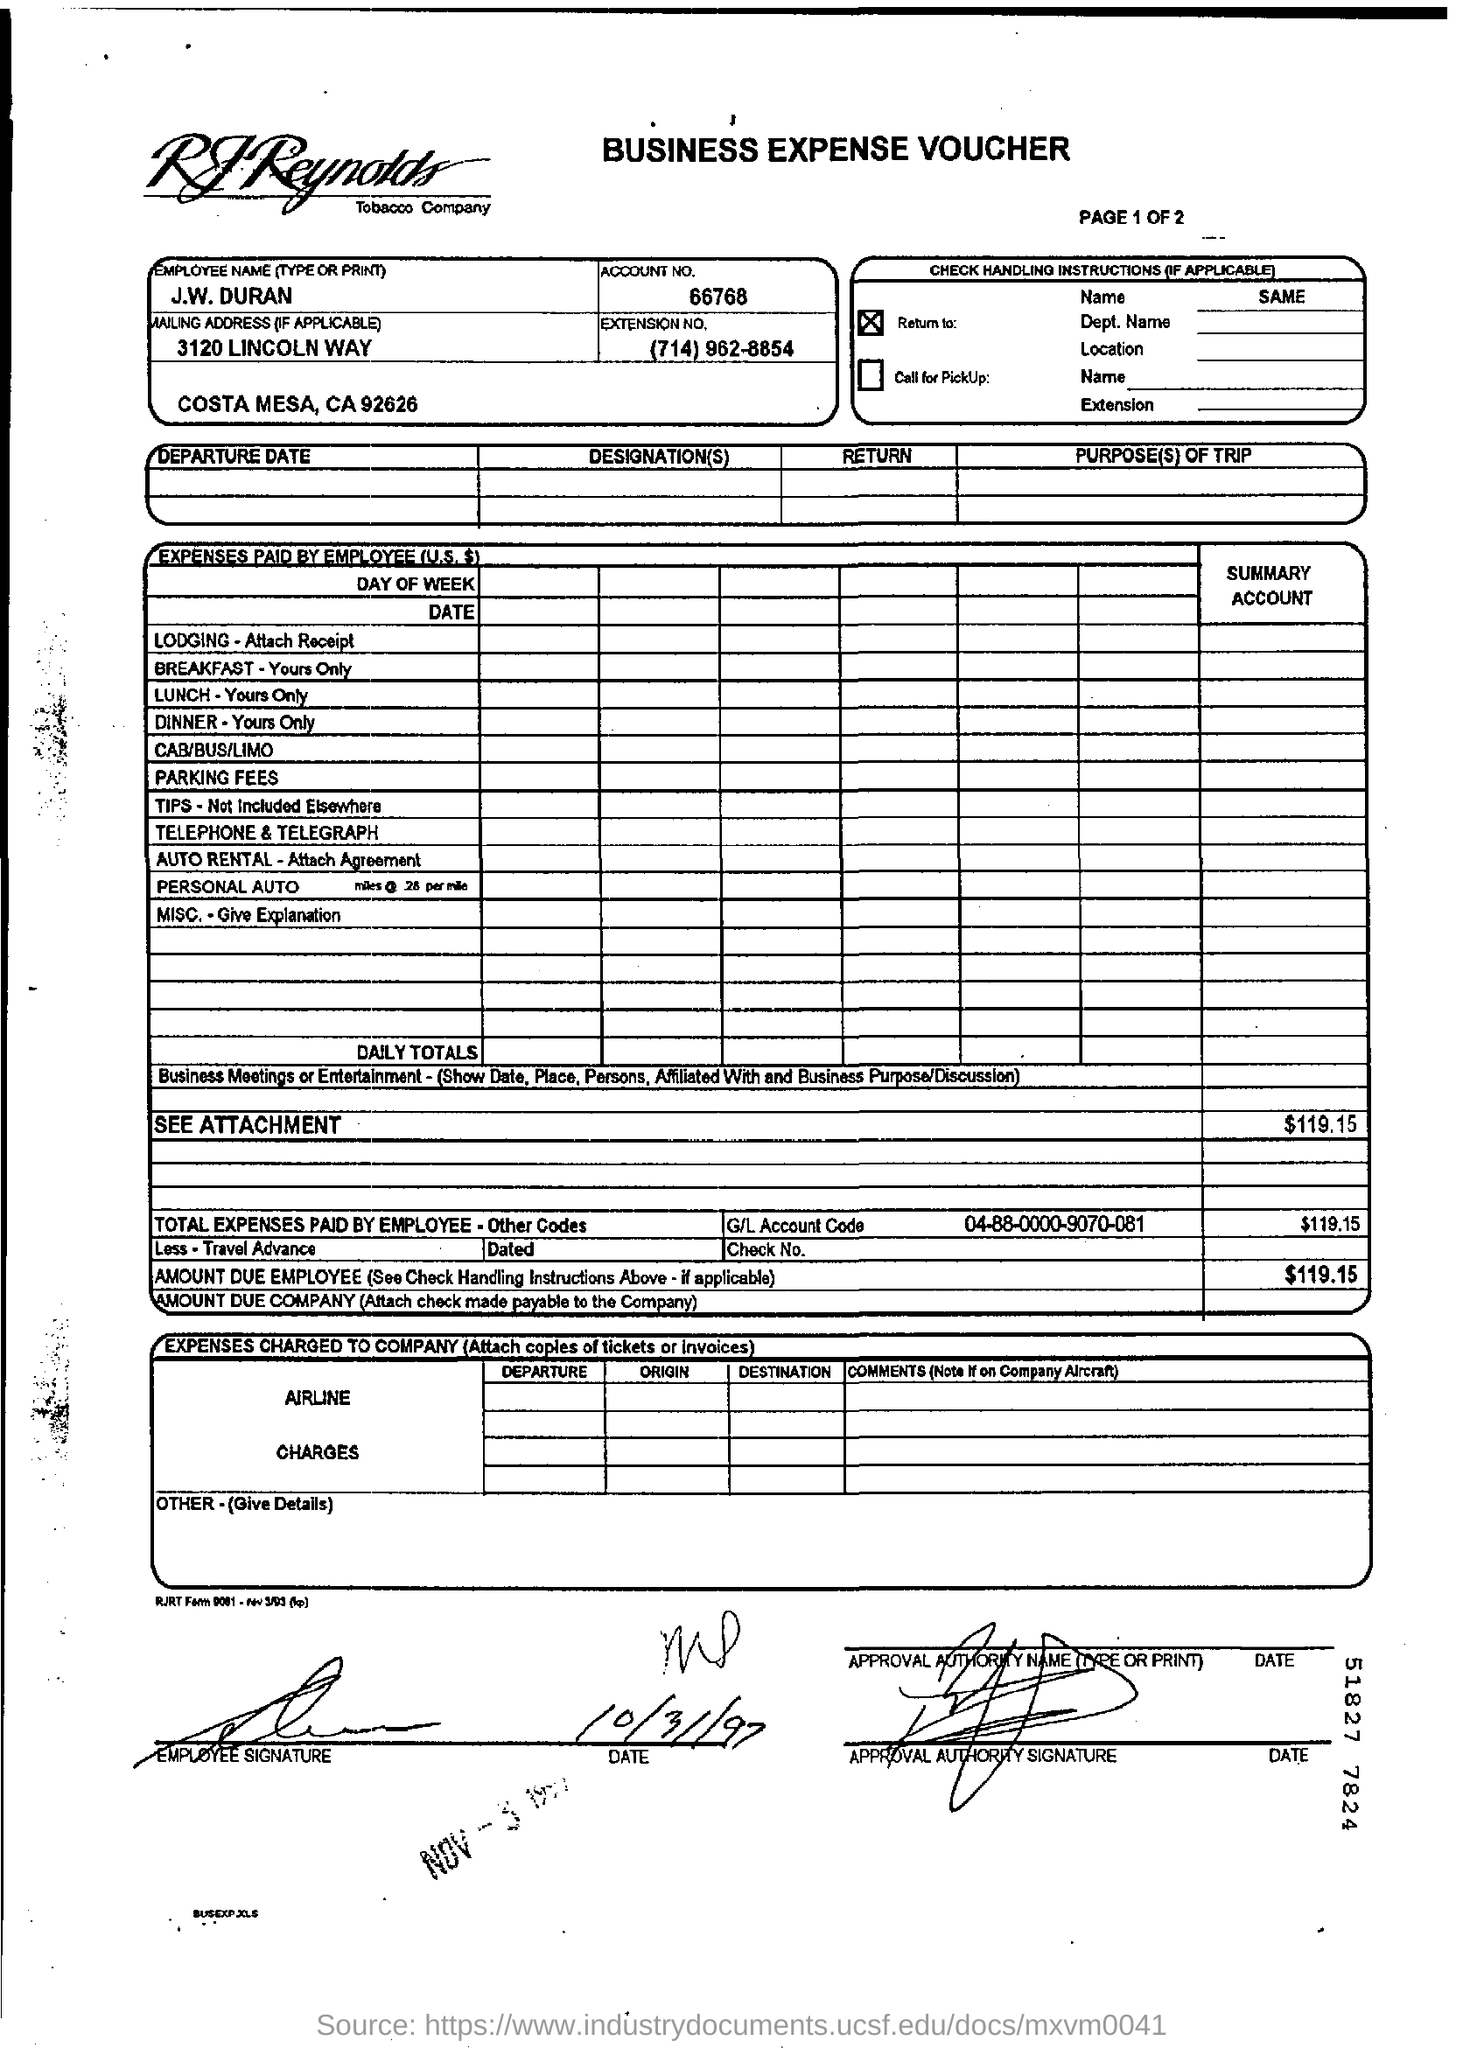What is the employee name?
Provide a short and direct response. J.w duran. What is the account number?
Offer a very short reply. 66768. What is the g/l account code?
Provide a succinct answer. 04-88-0000-9070-081. 